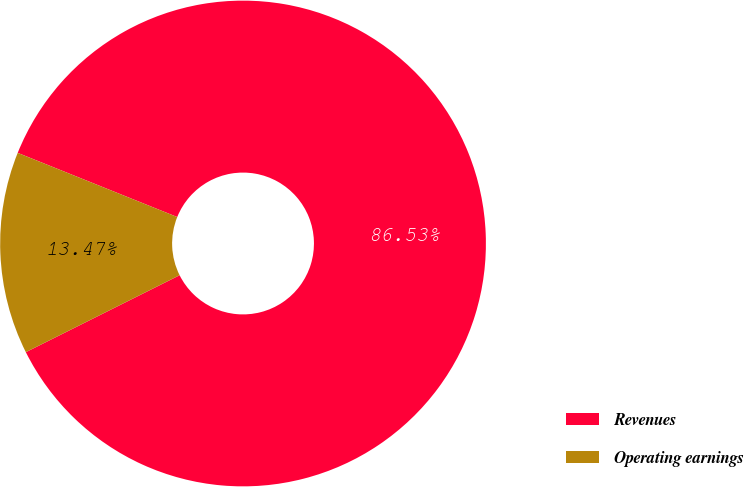Convert chart to OTSL. <chart><loc_0><loc_0><loc_500><loc_500><pie_chart><fcel>Revenues<fcel>Operating earnings<nl><fcel>86.53%<fcel>13.47%<nl></chart> 